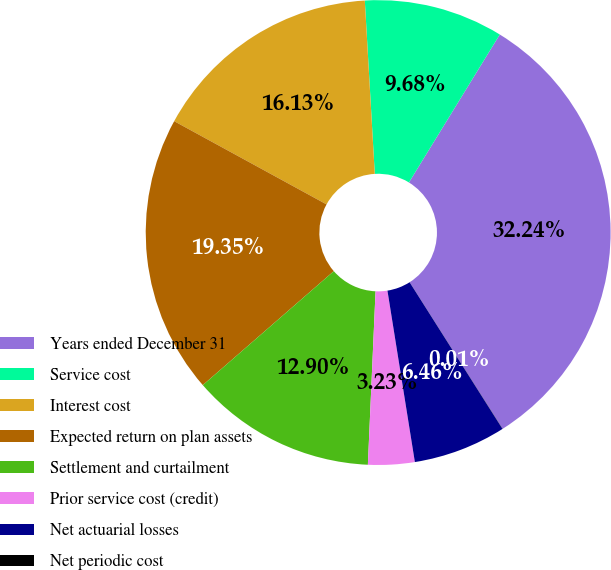Convert chart to OTSL. <chart><loc_0><loc_0><loc_500><loc_500><pie_chart><fcel>Years ended December 31<fcel>Service cost<fcel>Interest cost<fcel>Expected return on plan assets<fcel>Settlement and curtailment<fcel>Prior service cost (credit)<fcel>Net actuarial losses<fcel>Net periodic cost<nl><fcel>32.24%<fcel>9.68%<fcel>16.13%<fcel>19.35%<fcel>12.9%<fcel>3.23%<fcel>6.46%<fcel>0.01%<nl></chart> 